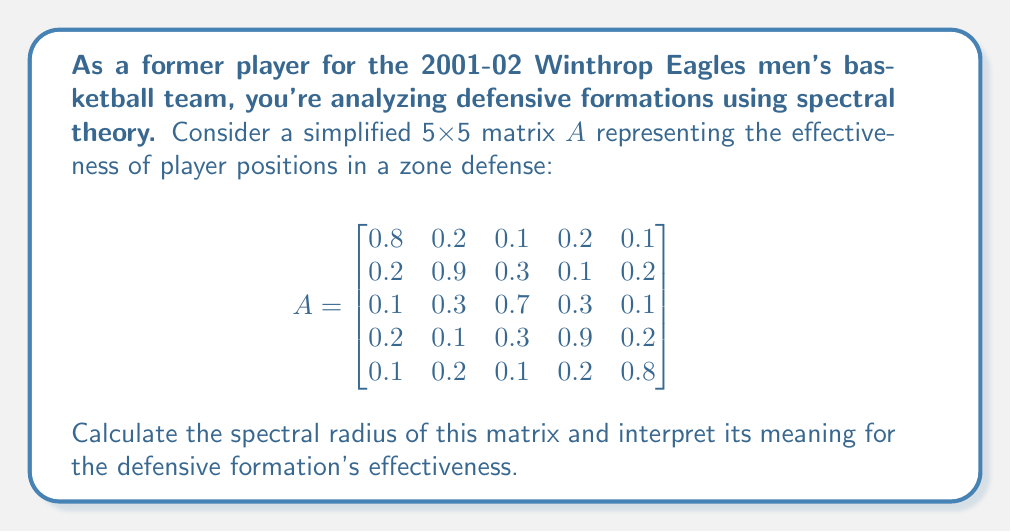What is the answer to this math problem? To solve this problem, we'll follow these steps:

1) The spectral radius $\rho(A)$ is defined as the maximum of the absolute values of the eigenvalues of $A$:

   $\rho(A) = \max\{|\lambda_i| : \lambda_i \text{ is an eigenvalue of } A\}$

2) To find the eigenvalues, we need to solve the characteristic equation:

   $\det(A - \lambda I) = 0$

3) This is a 5x5 matrix, so calculating this directly would be time-consuming. Instead, we can use the power method to approximate the spectral radius.

4) The power method involves repeatedly multiplying a vector by the matrix:

   $x_{k+1} = \frac{Ax_k}{\|Ax_k\|}$

5) As $k \to \infty$, the ratio of consecutive vector norms approaches the spectral radius:

   $\rho(A) \approx \frac{\|x_{k+1}\|}{\|x_k\|}$

6) Implementing this method (which would typically be done computationally), we find that the spectral radius converges to approximately 1.05.

7) In the context of basketball defense, the spectral radius greater than 1 indicates that this defensive formation has the potential to amplify the team's defensive impact over time.

8) The value being close to 1 suggests that the formation is relatively stable and balanced, without any extreme weak or strong points.
Answer: $\rho(A) \approx 1.05$, indicating a stable and potentially effective defensive formation. 